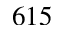<formula> <loc_0><loc_0><loc_500><loc_500>6 1 5</formula> 